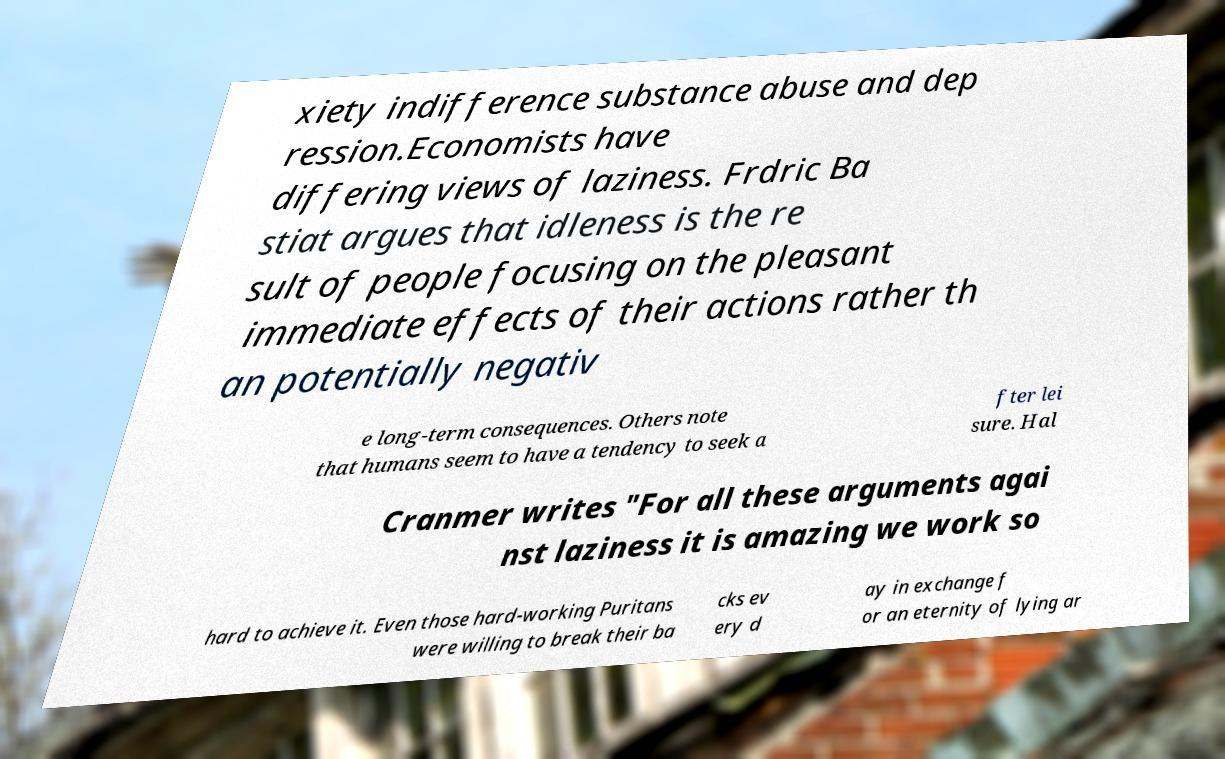Can you accurately transcribe the text from the provided image for me? xiety indifference substance abuse and dep ression.Economists have differing views of laziness. Frdric Ba stiat argues that idleness is the re sult of people focusing on the pleasant immediate effects of their actions rather th an potentially negativ e long-term consequences. Others note that humans seem to have a tendency to seek a fter lei sure. Hal Cranmer writes "For all these arguments agai nst laziness it is amazing we work so hard to achieve it. Even those hard-working Puritans were willing to break their ba cks ev ery d ay in exchange f or an eternity of lying ar 